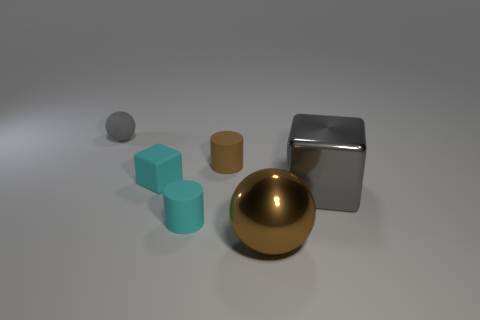Add 3 large green rubber balls. How many objects exist? 9 Subtract all balls. How many objects are left? 4 Add 1 small rubber things. How many small rubber things are left? 5 Add 4 small green shiny cubes. How many small green shiny cubes exist? 4 Subtract 0 purple spheres. How many objects are left? 6 Subtract all gray cubes. Subtract all large brown metal balls. How many objects are left? 4 